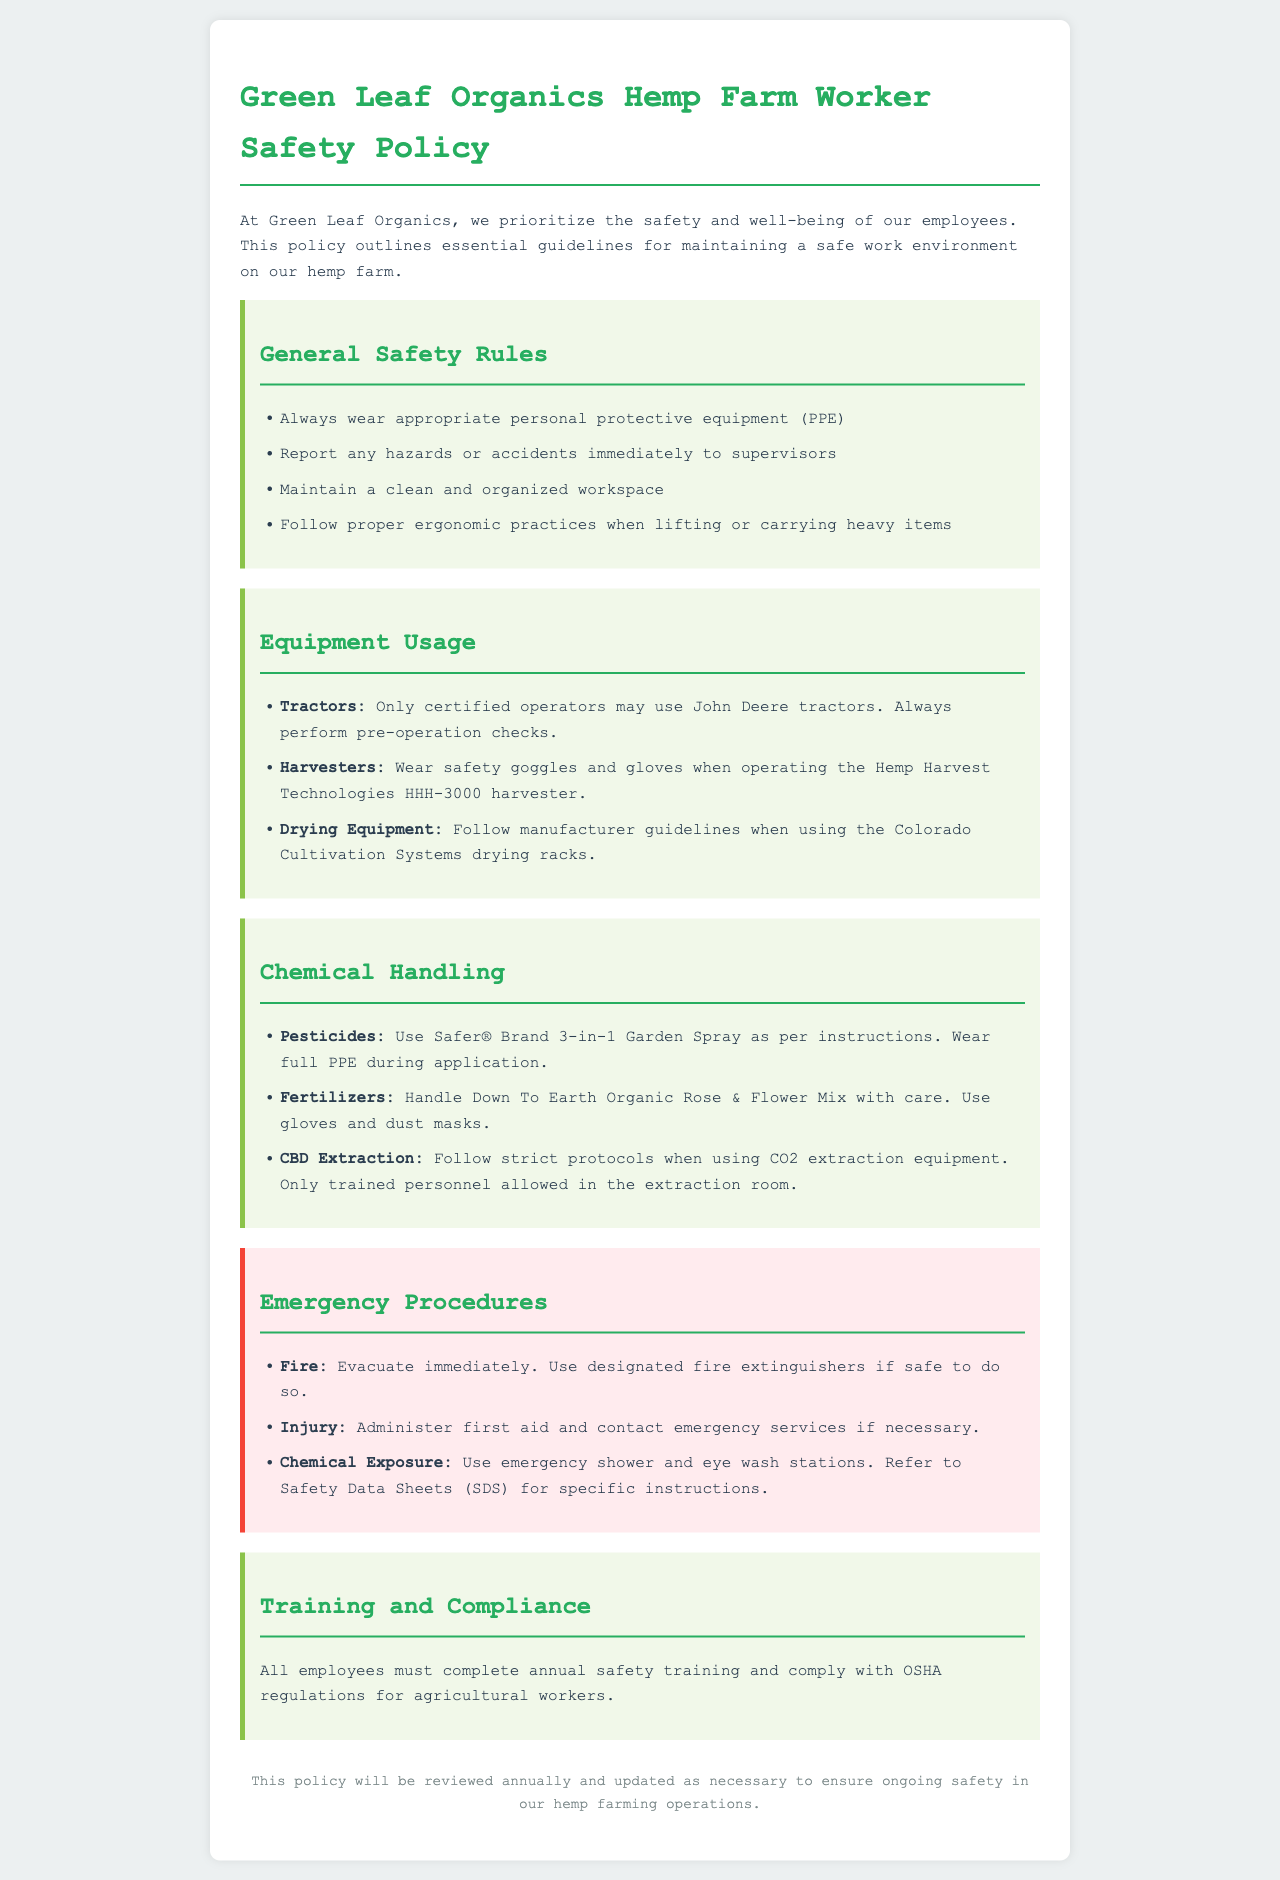What is the title of the policy document? The title is explicitly stated at the beginning of the document, which is "Green Leaf Organics Hemp Farm Worker Safety Policy."
Answer: Green Leaf Organics Hemp Farm Worker Safety Policy What is required personal protective equipment when handling pesticides? The document states that full PPE must be worn during pesticide application for safety.
Answer: Full PPE Which equipment requires certified operators for usage? The document specifies that only certified operators may use John Deere tractors, indicating a requirement for both training and safety.
Answer: John Deere tractors What should employees do in case of an injury? The procedures detail that first aid should be administered and emergency services contacted in the event of an injury.
Answer: Administer first aid and contact emergency services How often must employees complete safety training? The training frequency is mentioned as annual in the training and compliance section of the document.
Answer: Annual What is the safety measure for chemical exposure? The document lists that emergency showers and eye wash stations should be used to mitigate exposures to harmful chemicals.
Answer: Emergency shower and eye wash stations What is the name of the pesticide mentioned in the document? The document specifies the use of Safer® Brand 3-in-1 Garden Spray as the pesticide recommended for employees.
Answer: Safer® Brand 3-in-1 Garden Spray What should be done if a fire occurs on the farm? The document advises immediate evacuation and the use of designated fire extinguishers if it is safe to do so, highlighting urgency in safety measures.
Answer: Evacuate immediately Which company manufactures the drying equipment? The drying equipment mentioned in the policy is produced by Colorado Cultivation Systems, indicating the source for equipment usage guidelines.
Answer: Colorado Cultivation Systems 